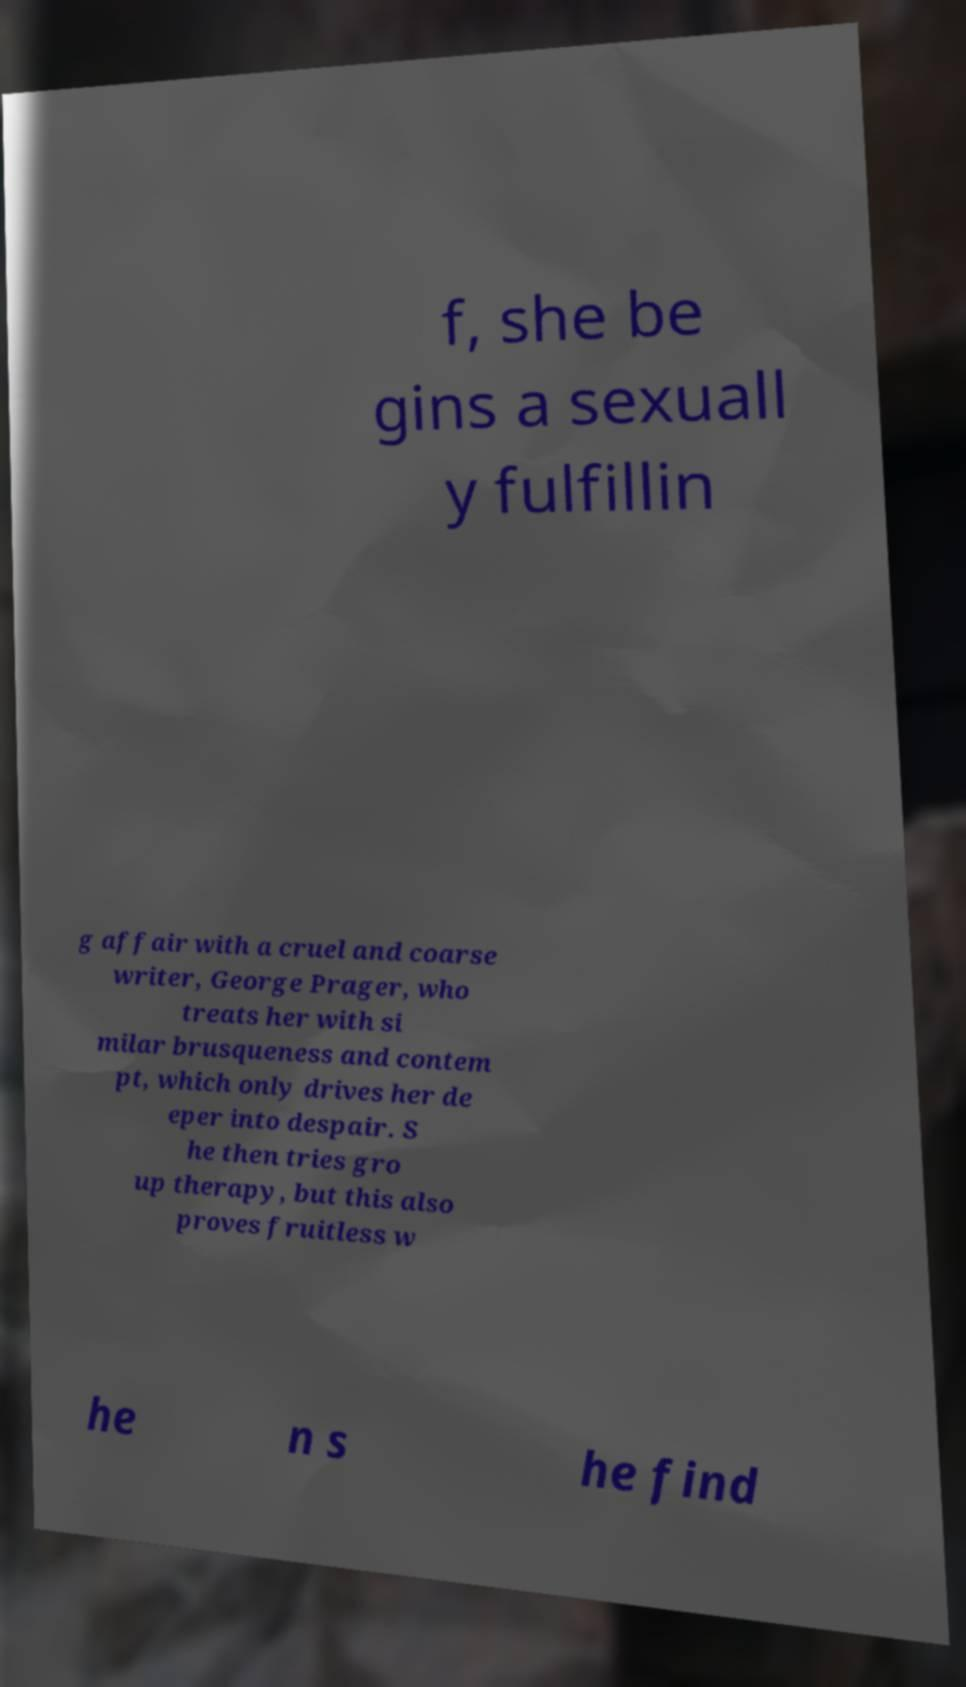Please read and relay the text visible in this image. What does it say? f, she be gins a sexuall y fulfillin g affair with a cruel and coarse writer, George Prager, who treats her with si milar brusqueness and contem pt, which only drives her de eper into despair. S he then tries gro up therapy, but this also proves fruitless w he n s he find 